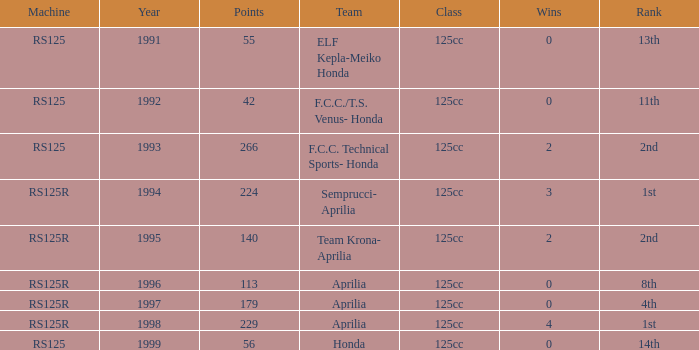In which group was there a machine of rs125r, points above 113, and a standing of 4th place? 125cc. 